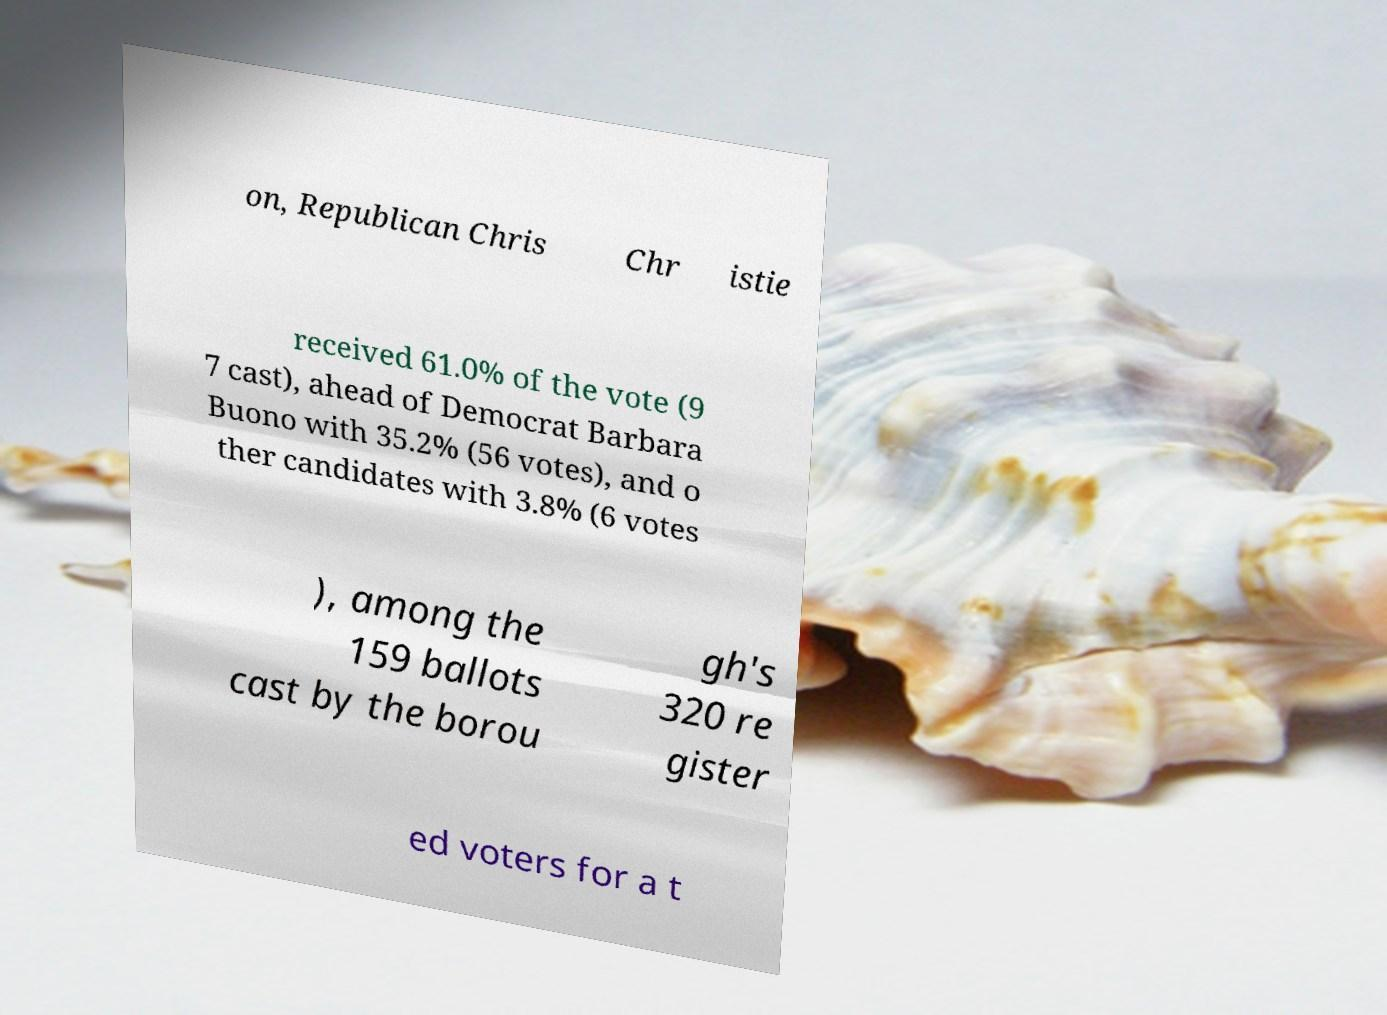Please identify and transcribe the text found in this image. on, Republican Chris Chr istie received 61.0% of the vote (9 7 cast), ahead of Democrat Barbara Buono with 35.2% (56 votes), and o ther candidates with 3.8% (6 votes ), among the 159 ballots cast by the borou gh's 320 re gister ed voters for a t 